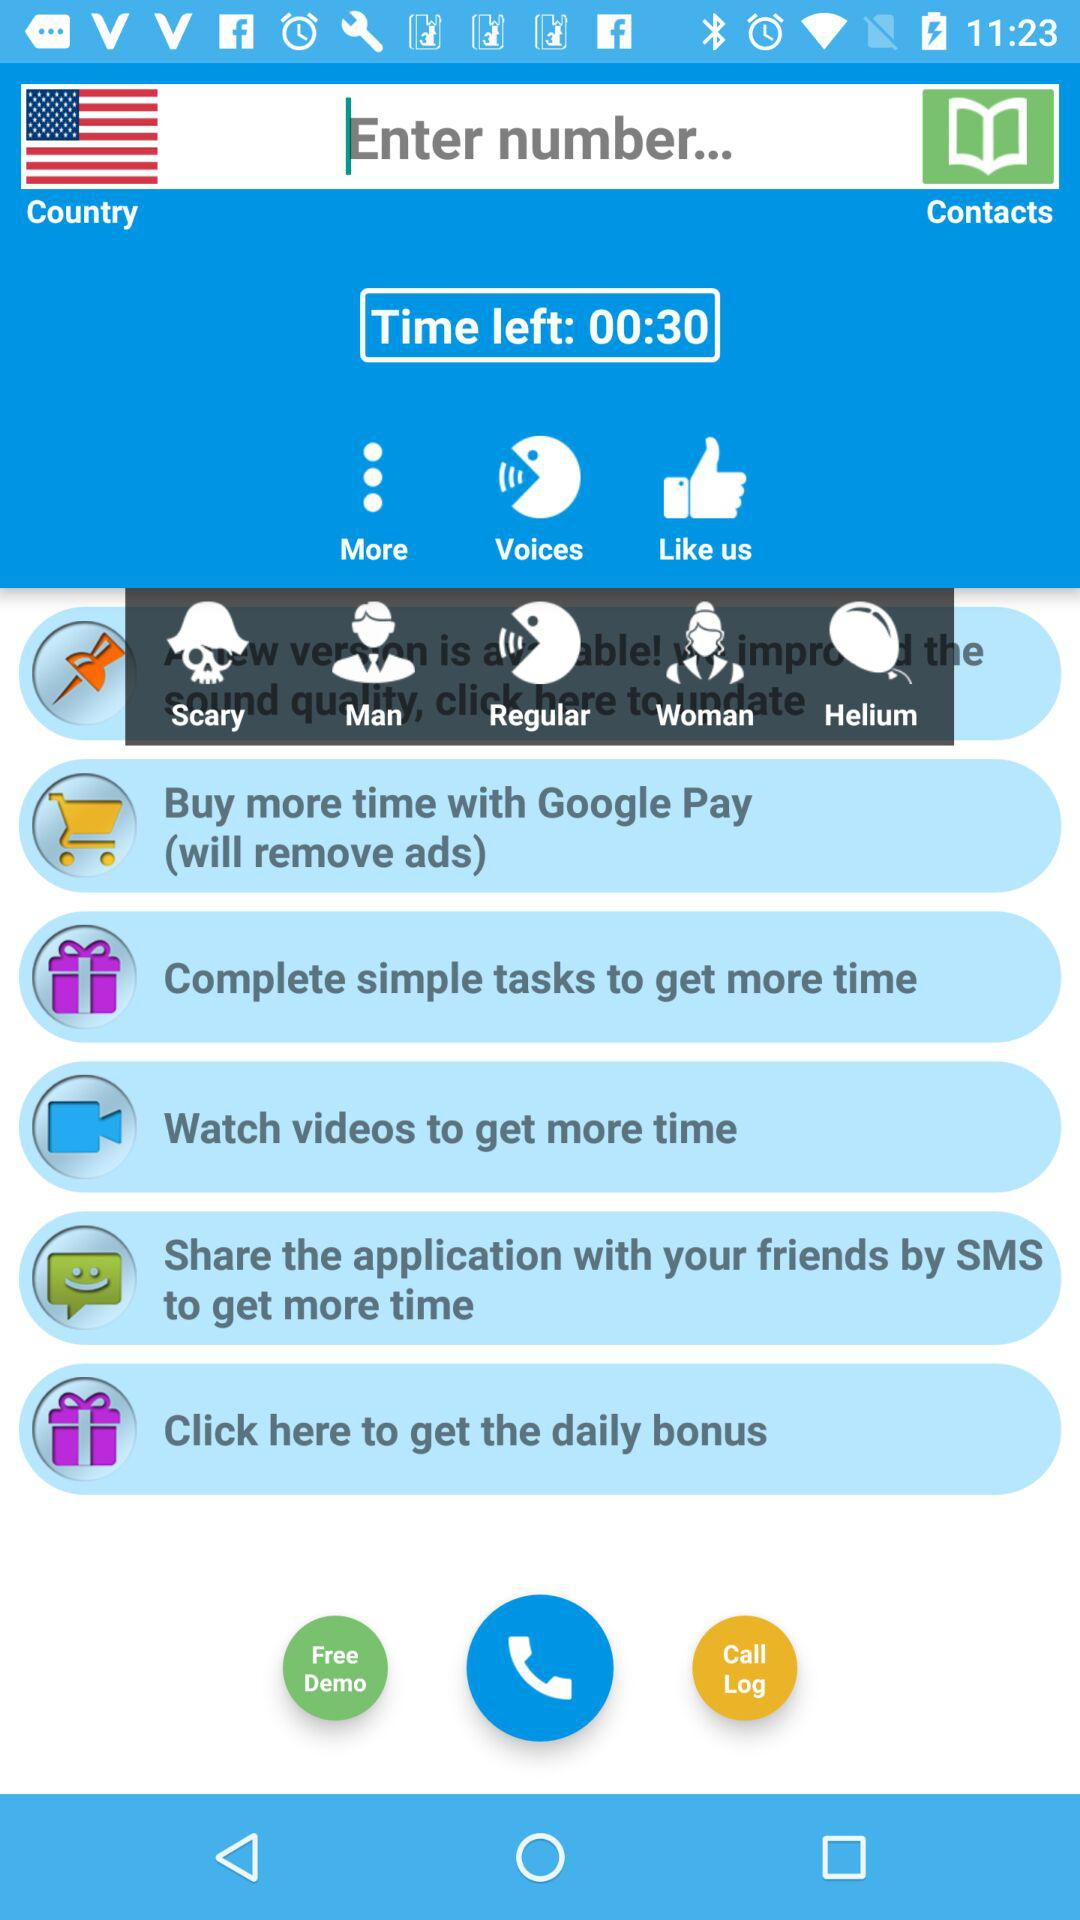By what method can we share the application with friends? We can share the application with friends by "SMS". 